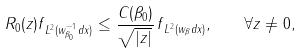<formula> <loc_0><loc_0><loc_500><loc_500>\| R _ { 0 } ( z ) f \| _ { L ^ { 2 } ( w _ { \beta _ { 0 } } ^ { - 1 } d x ) } \leq \frac { C ( \beta _ { 0 } ) } { \sqrt { | z | } } \, \| f \| _ { L ^ { 2 } ( w _ { \beta } d x ) } , \quad \forall z \neq 0 ,</formula> 